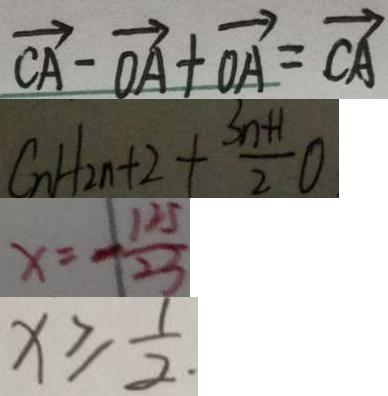Convert formula to latex. <formula><loc_0><loc_0><loc_500><loc_500>\overrightarrow { C A } - \overrightarrow { O A } + \overrightarrow { O A } = \overrightarrow { C A } 
 C n H 2 n + 2 + \frac { 3 n + 1 } { 2 } 0 
 x = - \frac { 1 2 5 } { 2 3 } 
 x \geq \frac { 1 } { 2 } .</formula> 